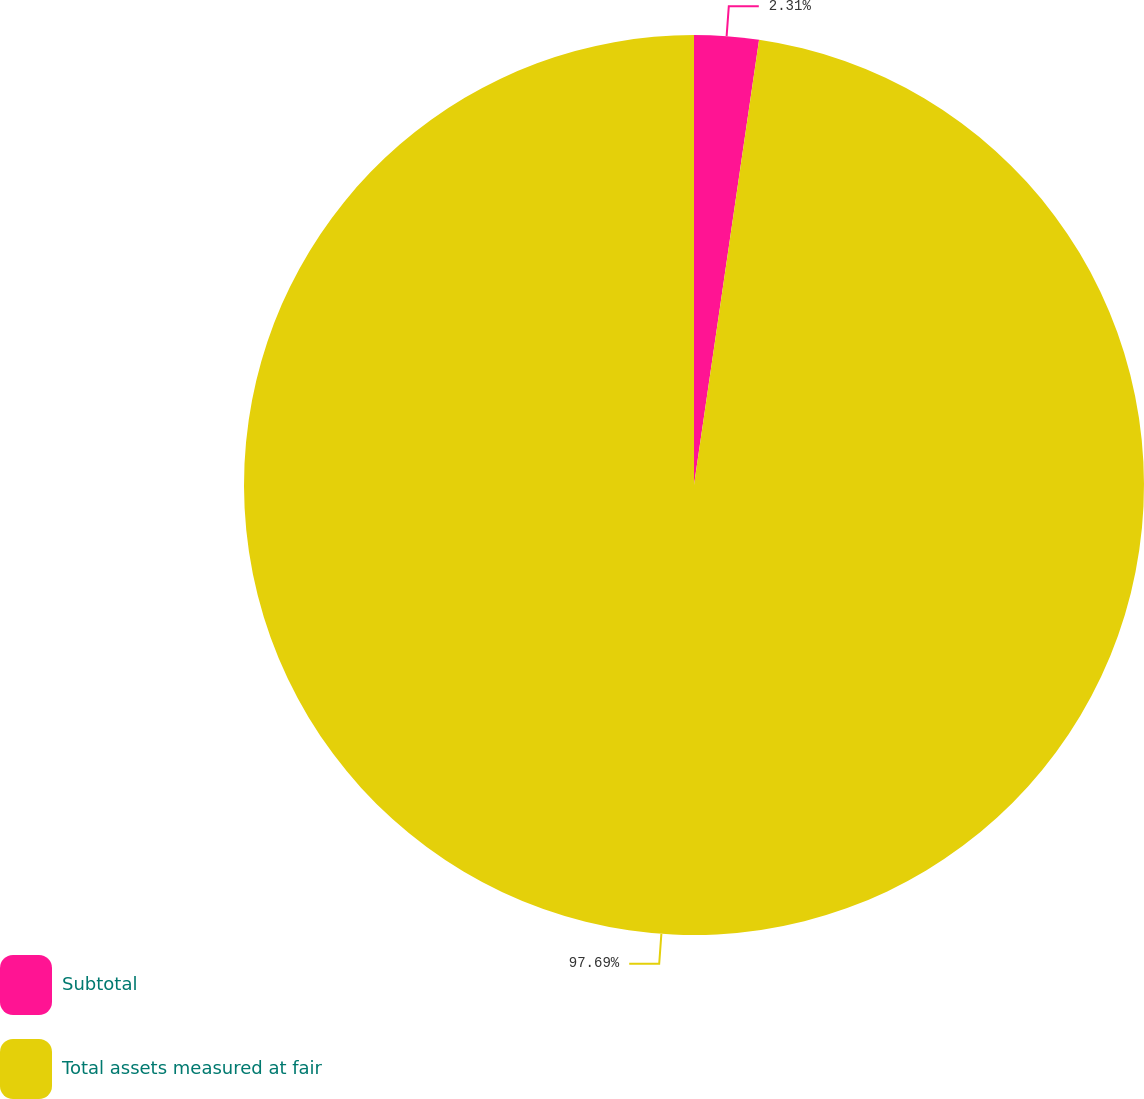Convert chart to OTSL. <chart><loc_0><loc_0><loc_500><loc_500><pie_chart><fcel>Subtotal<fcel>Total assets measured at fair<nl><fcel>2.31%<fcel>97.69%<nl></chart> 